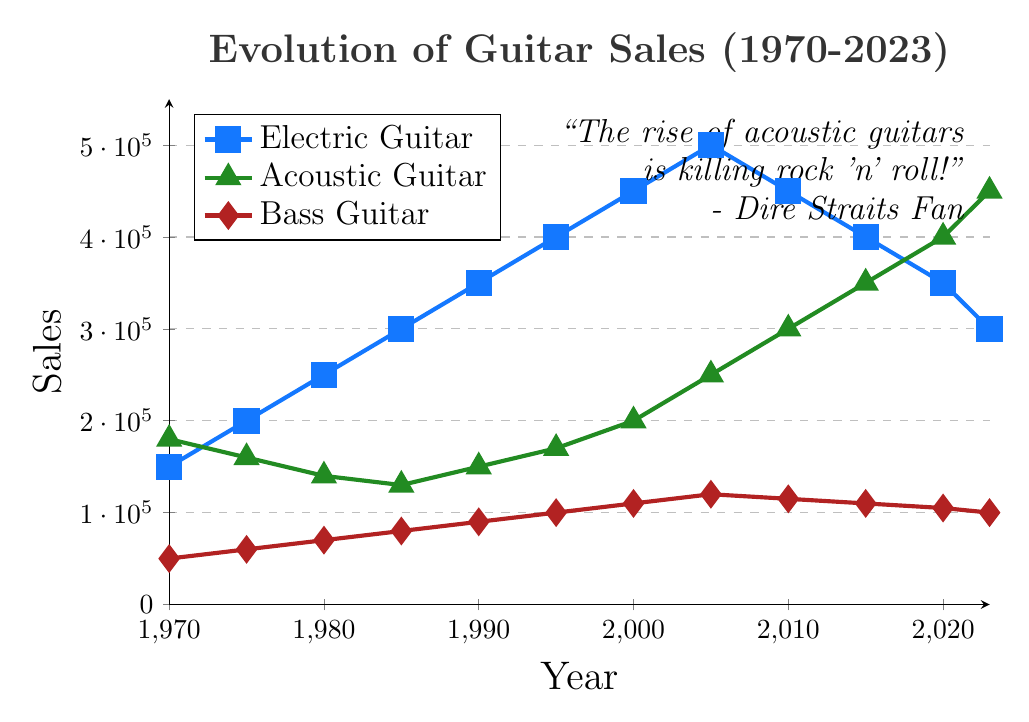What was the highest sales figure achieved by electric guitars between 1970 and 2023? The highest sales figure for electric guitars can be seen in the visualization as 500,000 units, which was achieved in 2005.
Answer: 500,000 How did the sales of acoustic guitars change from 1970 to 2023? In 1970, acoustic guitar sales were at 180,000 units and by 2023 they increased to 450,000 units. This represents a steady rise in sales of acoustic guitars over the period.
Answer: Increased by 270,000 units By how much did the sales of bass guitars increase from 1970 to 2005? In 1970, bass guitar sales were 50,000 units and increased to 120,000 units by 2005. The difference between these years is 120,000 - 50,000 = 70,000 units.
Answer: Increased by 70,000 units Which type of guitar had the highest sales in 2020? In 2020, the visualization shows that acoustic guitars had the highest sales with 400,000 units, compared to 350,000 units for electric guitars and 105,000 units for bass guitars.
Answer: Acoustic Guitar Between which consecutive years did electric guitar sales see the greatest decrease? The greatest decrease in electric guitar sales occurred between 2005 and 2010, dropping from 500,000 units to 450,000 units. This is a decline of 50,000 units.
Answer: 2005 to 2010 What is the trend in bass guitar sales from 1970 to 2023? The trend in bass guitar sales from 1970 to 2023 shows an overall increase from 50,000 units to 100,000 units, though there are some minor fluctuations in the later years.
Answer: Overall Increase Compare the sales of electric and acoustic guitars in 2010. What's the difference? In 2010, electric guitar sales were at 450,000 units, while acoustic guitar sales were at 300,000 units. The difference is 450,000 - 300,000 = 150,000 units.
Answer: 150,000 units What is the average sales of electric guitars over the given years? The total sales of electric guitars over the given years is the sum of each year's sales: (150,000 + 200,000 + 250,000 + 300,000 + 350,000 + 400,000 + 450,000 + 500,000 + 450,000 + 400,000 + 350,000 + 300,000) = 4,100,000 units. There are 12 data points, so the average is 4,100,000 / 12 = 341,667 units.
Answer: 341,667 units 